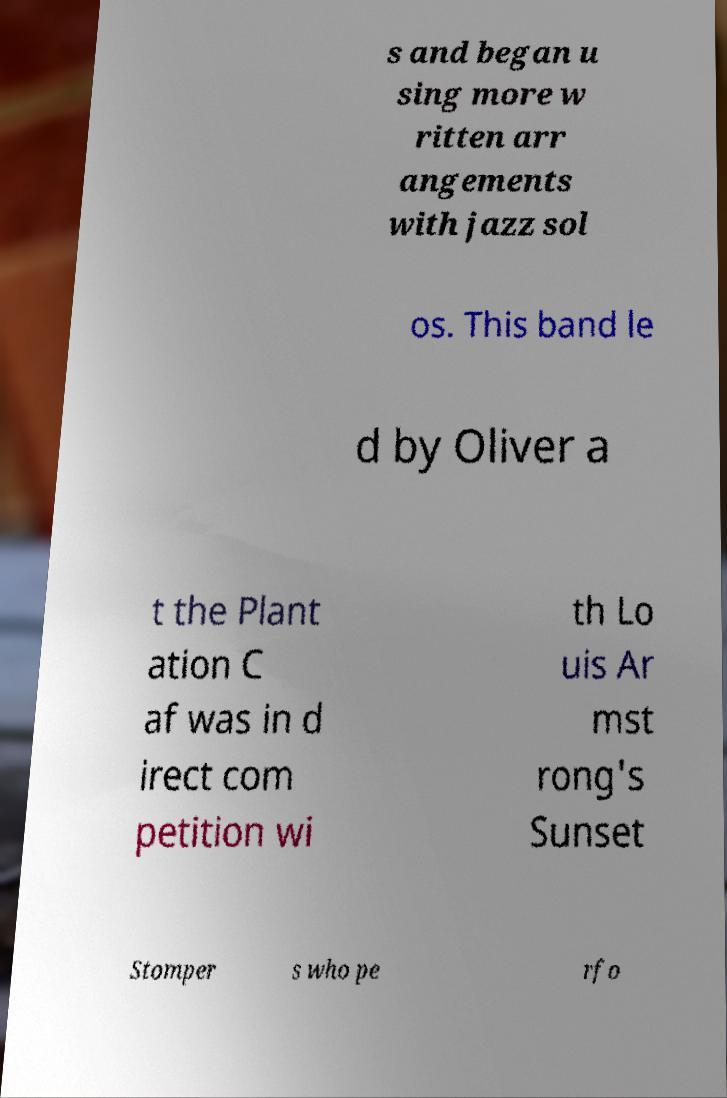Please read and relay the text visible in this image. What does it say? s and began u sing more w ritten arr angements with jazz sol os. This band le d by Oliver a t the Plant ation C af was in d irect com petition wi th Lo uis Ar mst rong's Sunset Stomper s who pe rfo 